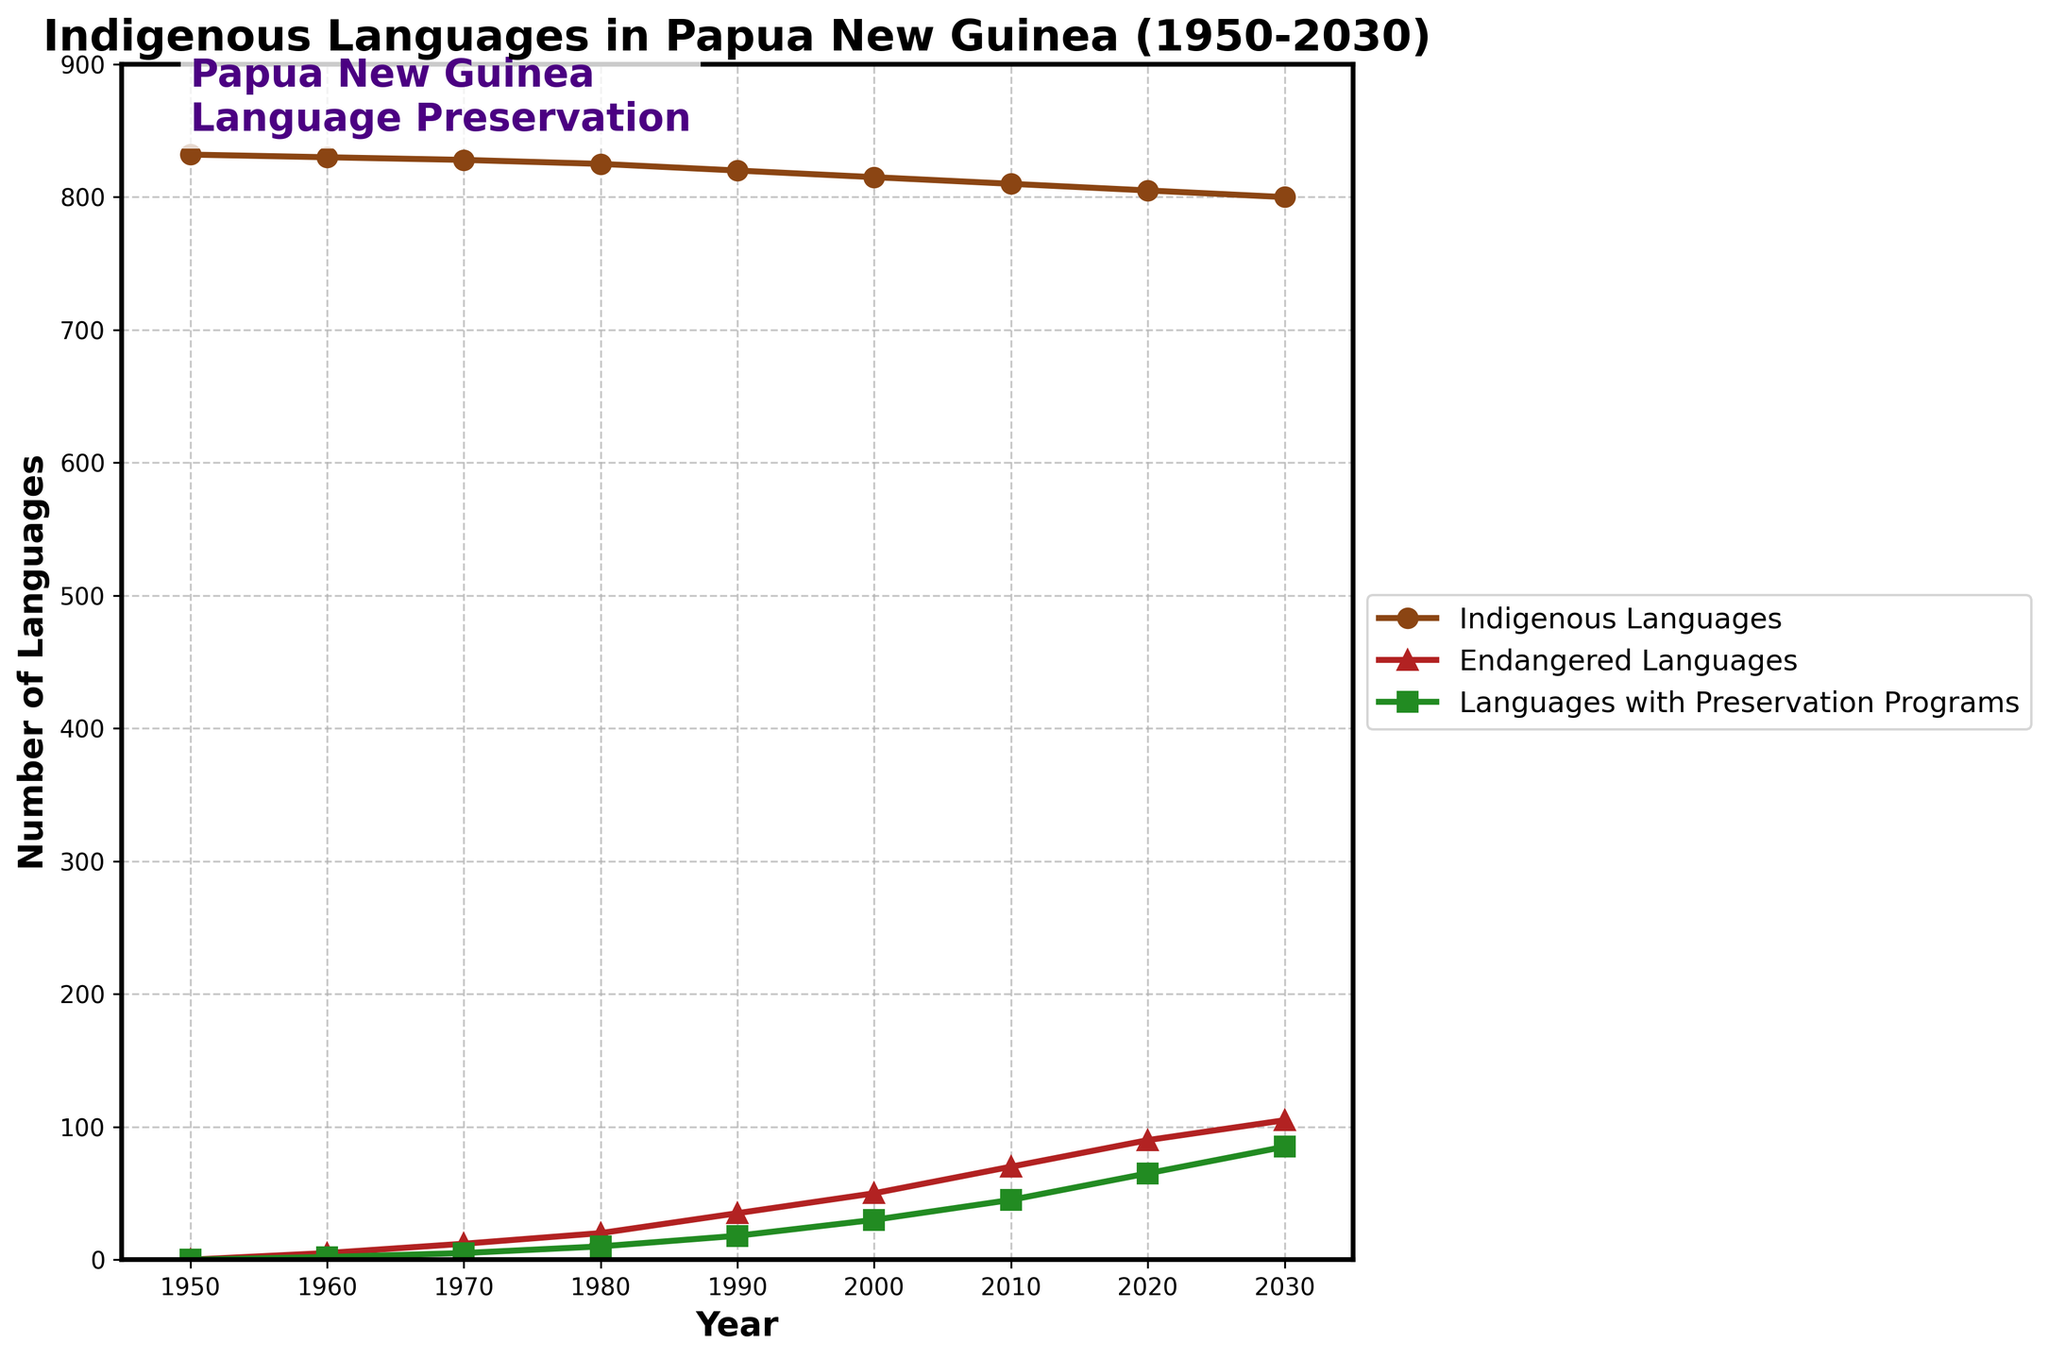What year had the highest number of indigenous languages? By inspecting the figure, the line for indigenous languages starts highest in 1950 at 832 and decreases every year thereafter. Thus, 1950 had the highest number.
Answer: 1950 Which category increased the most over the years? To determine this, we can observe the change in numbers from 1950 to 2030 for each category. Indigenous languages decreased, endangered languages and languages with preservation programs increased significantly, with endangered languages increasing from 0 to 105 and languages with preservation programs from 0 to 85. Endangered languages show the largest increase.
Answer: Endangered Languages How many indigenous languages are not endangered in the year 2020? The number of indigenous languages in 2020 is 805, and the number of endangered languages in the same year is 90. Subtracting the endangered languages from the total indigenous languages gives 805 - 90.
Answer: 715 In which year did languages with preservation programs first exceed 50? By following the green line representing languages with preservation programs, we can see that it exceeds 50 between the years 2010 and 2020. It first exceeds 50 in 2020.
Answer: 2020 Compare the number of endangered languages and languages with preservation programs in 2030. Which is greater and by how much? In 2030, the number of endangered languages is 105, while the number of languages with preservation programs is 85. To find the difference, subtract 85 from 105.
Answer: Endangered Languages, 20 What is the rate of decline per decade in the number of indigenous languages from 1950 to 2030? The number of indigenous languages declined from 832 in 1950 to 800 in 2030. The decline over 80 years is 832 - 800 = 32. Dividing by 8 decades gives the rate per decade as 32 / 8.
Answer: 4 languages per decade Are there more endangered languages or indigenous languages without preservation programs in 2010? In 2010, there are 810 indigenous languages and 70 endangered languages. Subtracting languages with preservation programs (45) from the total gives 810 - 45 = 765. Comparing 70 endangered with 765 languages without preservation programs shows more in the latter category.
Answer: Indigenous languages without preservation programs Determine the change in the number of languages with preservation programs between 1980 and 2020. The number of languages with preservation programs in 1980 is 10 and in 2020 is 65. The change is obtained by subtracting 10 from 65.
Answer: 55 In which year did the number of endangered languages surpass the number of languages with preservation programs, and by how much? By comparing the lines for endangered languages and languages with preservation programs, this happens in 2000 when endangered languages (50) surpass preservation programs (30). The difference is 50 - 30.
Answer: 2000, 20 